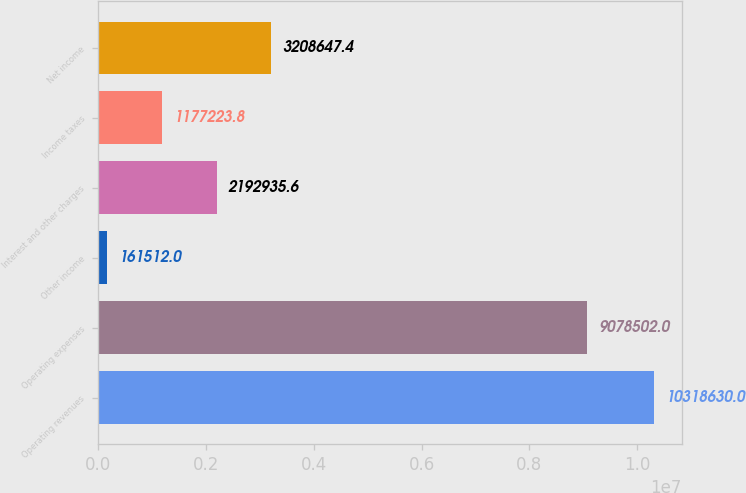Convert chart to OTSL. <chart><loc_0><loc_0><loc_500><loc_500><bar_chart><fcel>Operating revenues<fcel>Operating expenses<fcel>Other income<fcel>Interest and other charges<fcel>Income taxes<fcel>Net income<nl><fcel>1.03186e+07<fcel>9.0785e+06<fcel>161512<fcel>2.19294e+06<fcel>1.17722e+06<fcel>3.20865e+06<nl></chart> 